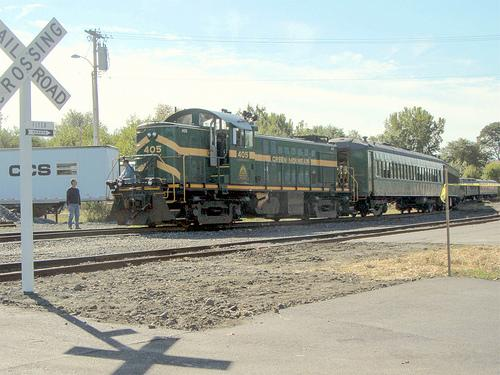Identify the type of sign and its position in the image. There is a white railroad crossing sign, located near the train tracks on a pole. Mention the primary object in the image and describe its appearance. The primary object in the image is a green train with yellow stripes, parked on the train tracks. Describe one of the smaller objects in the image in relation to the main subject. A yellow flag on a stick is visible close to the green train with yellow stripes. Describe a prominent action being performed by a human subject in the image. A man is standing beside the railroad tracks, engaged in a conversation with another person. Discuss the main transportation-related elements visible in the image. The main transportation-related elements are a green train with yellow stripes, train tracks, and a white railroad crossing sign. Briefly describe the scene taking place near a parked vehicle in the image. Near a parked green train, a man is standing beside the railroad tracks, talking to another person. Provide an overview of the setting and environment in the image. The image is set at a train station with train tracks, a green train, railroad crossing signs, and people engaged in activities. Explain what the main focus of the image is and what people are doing around it. The main focus is a parked green train, and people are standing and sitting near the train, having conversations and observing. Detail any visible text or numbers in the image and their locations. There are numbers on the front of the green train and "ccs" on the side of a white trailer. List the main objects and subjects in the image along with their respective colors. Answer: Green train with a yellow line, white railroad crossing sign, and people wearing mixed colored clothes. 